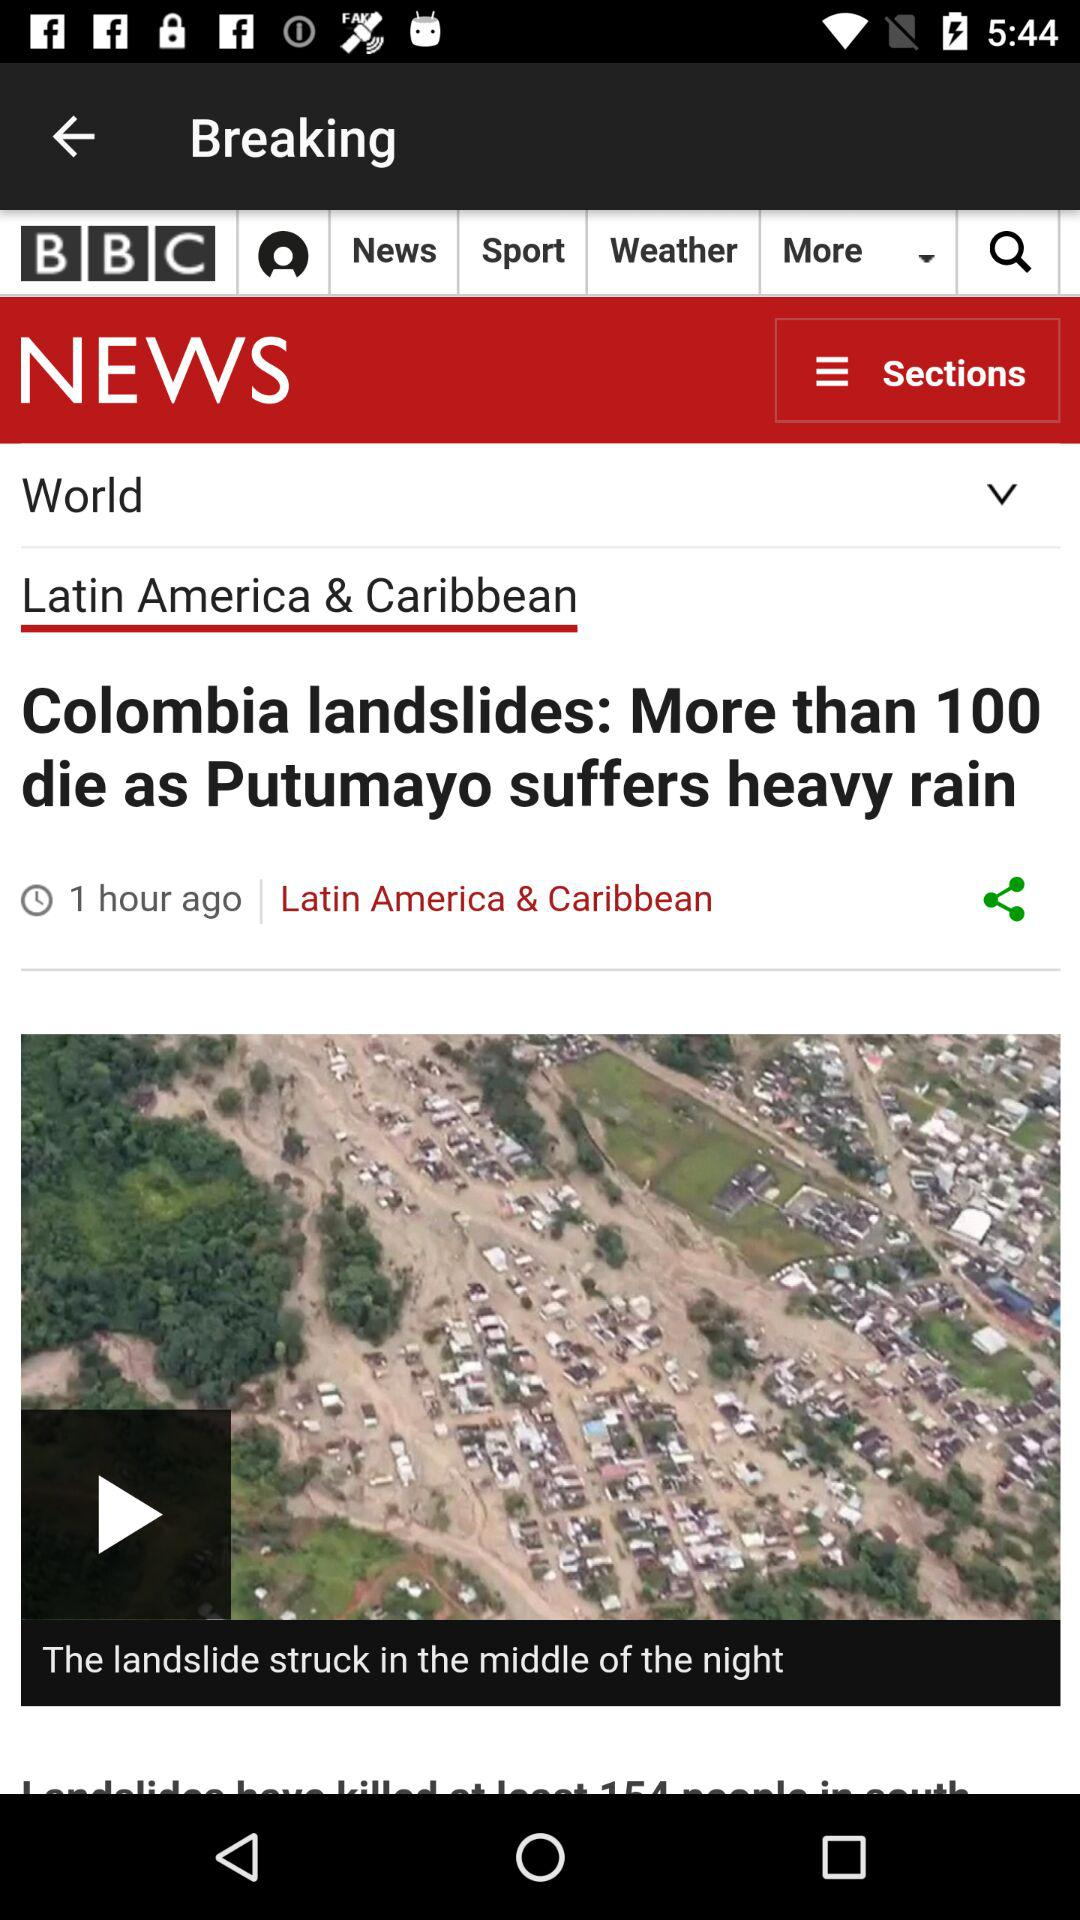What is the time duration of the video?
When the provided information is insufficient, respond with <no answer>. <no answer> 